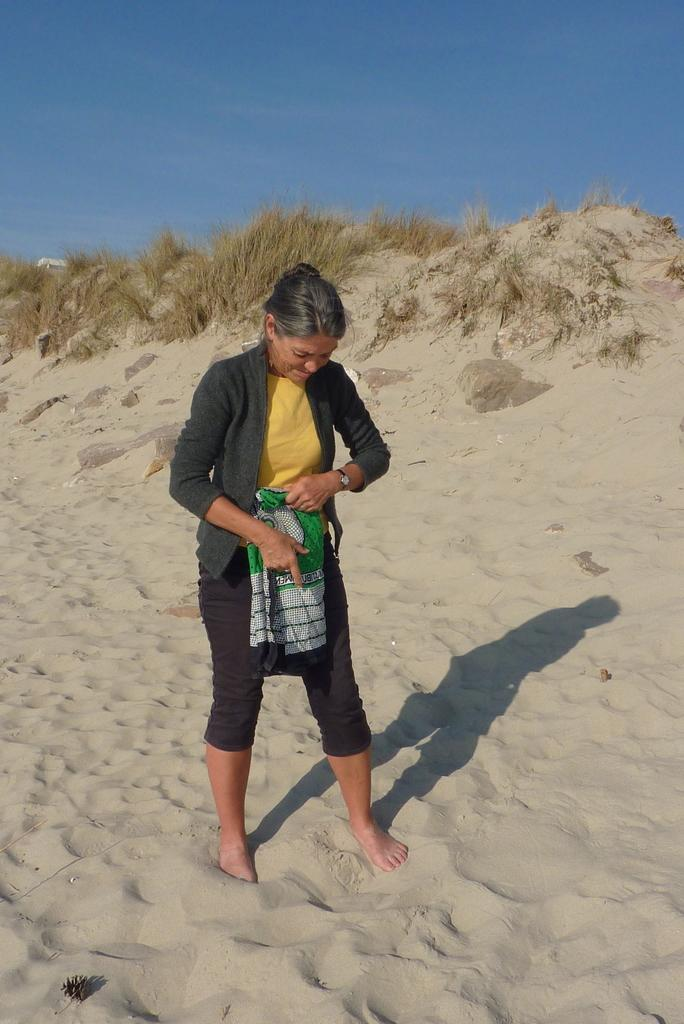Who is present in the image? There is a woman in the image. What is the woman doing in the image? The woman is standing in the image. What is the woman holding in her hands? The woman is holding a cloth in her hands. What can be seen in the background of the image? There are plants visible in the image. What is the woman wearing in the image? The woman is wearing a black coat in the image. What is the color of the sky in the image? The sky is blue in the image. What type of farm animals can be seen in the image? There are no farm animals present in the image. What is the woman's friend doing in the image? There is no friend present in the image. 